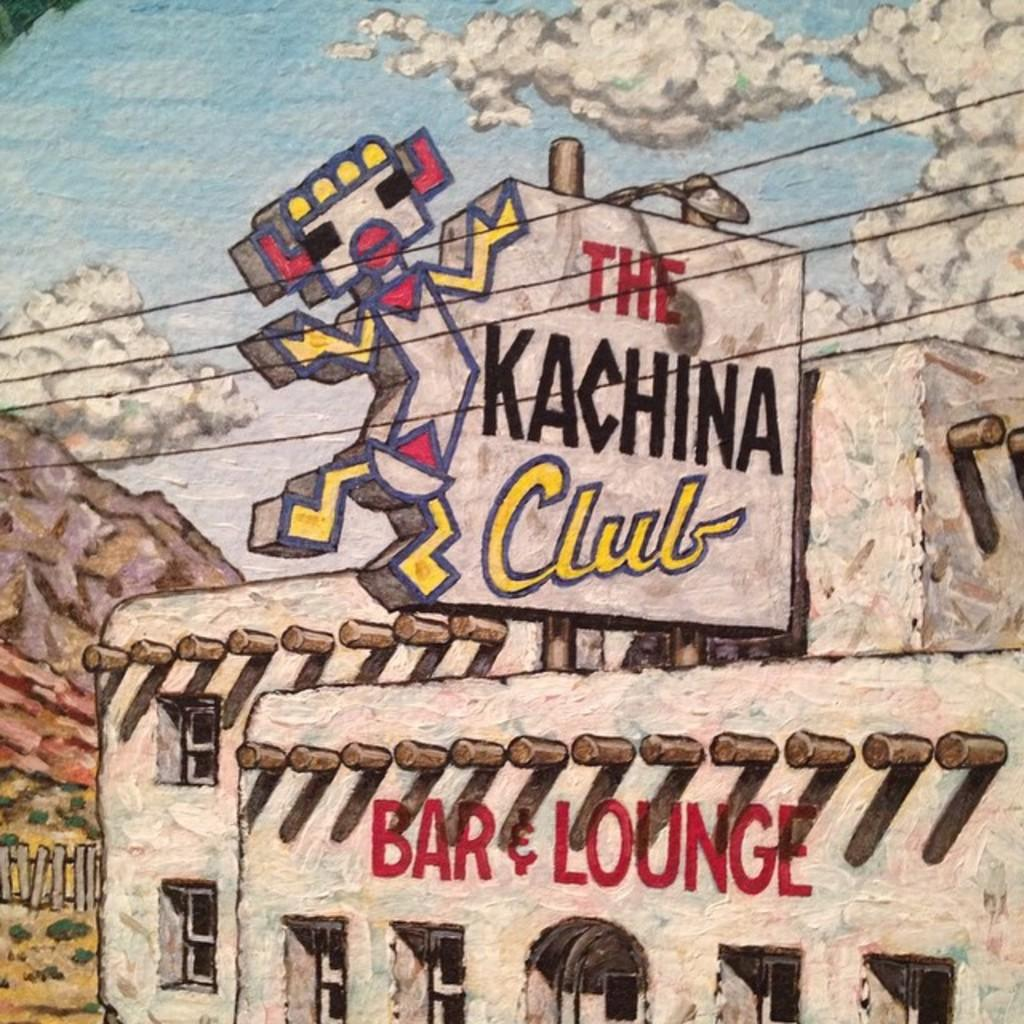What is the main subject of the painting in the image? The main subject of the painting in the image is a building. What else is depicted in the painting besides the building? The painting includes a depiction of the sky and trees. Where is the scarecrow located in the painting? There is no scarecrow present in the painting; it only includes a depiction of a building, the sky, and trees. 